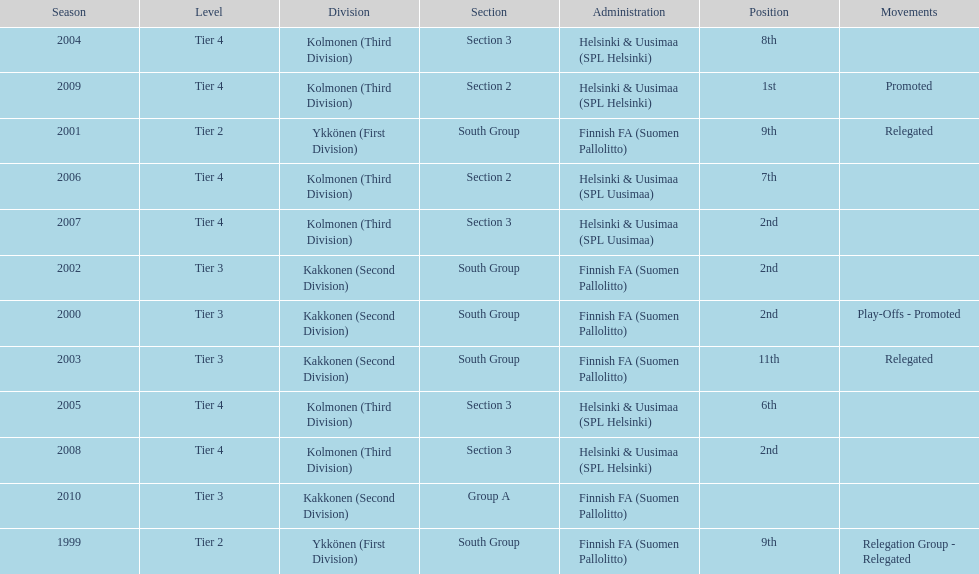Which administration has the least amount of division? Helsinki & Uusimaa (SPL Helsinki). 